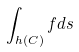Convert formula to latex. <formula><loc_0><loc_0><loc_500><loc_500>\int _ { h ( C ) } f d s</formula> 